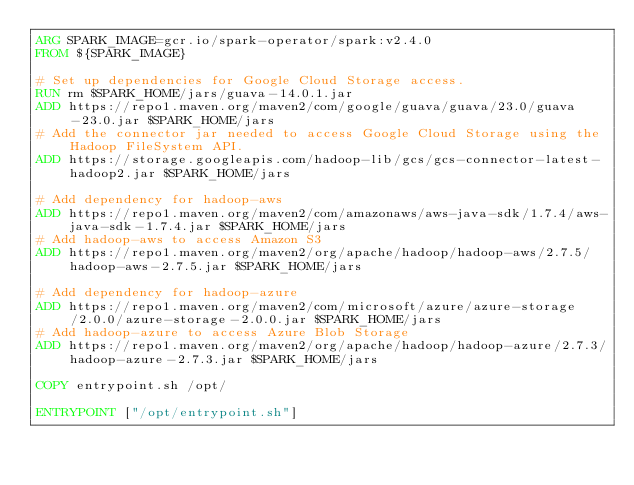<code> <loc_0><loc_0><loc_500><loc_500><_Dockerfile_>ARG SPARK_IMAGE=gcr.io/spark-operator/spark:v2.4.0
FROM ${SPARK_IMAGE}

# Set up dependencies for Google Cloud Storage access.
RUN rm $SPARK_HOME/jars/guava-14.0.1.jar
ADD https://repo1.maven.org/maven2/com/google/guava/guava/23.0/guava-23.0.jar $SPARK_HOME/jars
# Add the connector jar needed to access Google Cloud Storage using the Hadoop FileSystem API.
ADD https://storage.googleapis.com/hadoop-lib/gcs/gcs-connector-latest-hadoop2.jar $SPARK_HOME/jars

# Add dependency for hadoop-aws
ADD https://repo1.maven.org/maven2/com/amazonaws/aws-java-sdk/1.7.4/aws-java-sdk-1.7.4.jar $SPARK_HOME/jars
# Add hadoop-aws to access Amazon S3
ADD https://repo1.maven.org/maven2/org/apache/hadoop/hadoop-aws/2.7.5/hadoop-aws-2.7.5.jar $SPARK_HOME/jars

# Add dependency for hadoop-azure
ADD https://repo1.maven.org/maven2/com/microsoft/azure/azure-storage/2.0.0/azure-storage-2.0.0.jar $SPARK_HOME/jars
# Add hadoop-azure to access Azure Blob Storage
ADD https://repo1.maven.org/maven2/org/apache/hadoop/hadoop-azure/2.7.3/hadoop-azure-2.7.3.jar $SPARK_HOME/jars

COPY entrypoint.sh /opt/

ENTRYPOINT ["/opt/entrypoint.sh"]
</code> 